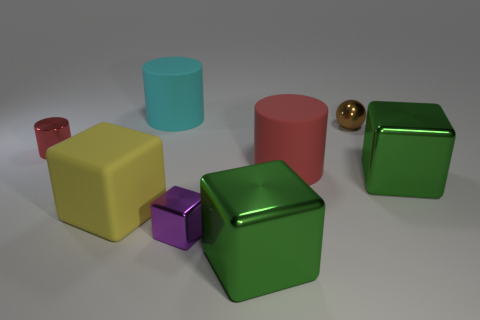Subtract all yellow cubes. How many cubes are left? 3 Subtract all red spheres. How many red cylinders are left? 2 Subtract 3 blocks. How many blocks are left? 1 Subtract all red cylinders. How many cylinders are left? 1 Add 1 matte objects. How many objects exist? 9 Subtract all cylinders. How many objects are left? 5 Subtract all green metal objects. Subtract all purple metallic blocks. How many objects are left? 5 Add 1 brown objects. How many brown objects are left? 2 Add 6 green blocks. How many green blocks exist? 8 Subtract 0 purple cylinders. How many objects are left? 8 